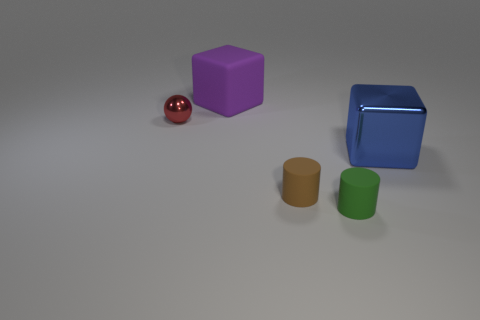Add 4 large purple cubes. How many objects exist? 9 Subtract all cylinders. How many objects are left? 3 Add 4 small red metallic objects. How many small red metallic objects exist? 5 Subtract 0 cyan balls. How many objects are left? 5 Subtract all brown shiny cubes. Subtract all large cubes. How many objects are left? 3 Add 2 big metallic objects. How many big metallic objects are left? 3 